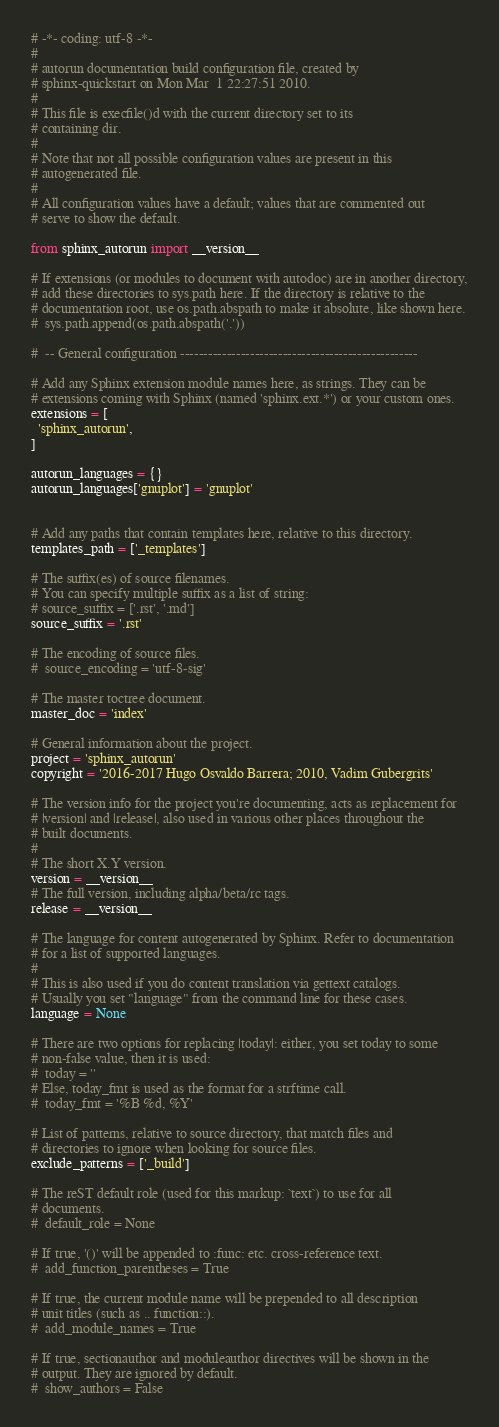Convert code to text. <code><loc_0><loc_0><loc_500><loc_500><_Python_># -*- coding: utf-8 -*-
#
# autorun documentation build configuration file, created by
# sphinx-quickstart on Mon Mar  1 22:27:51 2010.
#
# This file is execfile()d with the current directory set to its
# containing dir.
#
# Note that not all possible configuration values are present in this
# autogenerated file.
#
# All configuration values have a default; values that are commented out
# serve to show the default.

from sphinx_autorun import __version__

# If extensions (or modules to document with autodoc) are in another directory,
# add these directories to sys.path here. If the directory is relative to the
# documentation root, use os.path.abspath to make it absolute, like shown here.
#  sys.path.append(os.path.abspath('.'))

#  -- General configuration ---------------------------------------------------

# Add any Sphinx extension module names here, as strings. They can be
# extensions coming with Sphinx (named 'sphinx.ext.*') or your custom ones.
extensions = [
  'sphinx_autorun',
]

autorun_languages = {}
autorun_languages['gnuplot'] = 'gnuplot'


# Add any paths that contain templates here, relative to this directory.
templates_path = ['_templates']

# The suffix(es) of source filenames.
# You can specify multiple suffix as a list of string:
# source_suffix = ['.rst', '.md']
source_suffix = '.rst'

# The encoding of source files.
#  source_encoding = 'utf-8-sig'

# The master toctree document.
master_doc = 'index'

# General information about the project.
project = 'sphinx_autorun'
copyright = '2016-2017 Hugo Osvaldo Barrera; 2010, Vadim Gubergrits'

# The version info for the project you're documenting, acts as replacement for
# |version| and |release|, also used in various other places throughout the
# built documents.
#
# The short X.Y version.
version = __version__
# The full version, including alpha/beta/rc tags.
release = __version__

# The language for content autogenerated by Sphinx. Refer to documentation
# for a list of supported languages.
#
# This is also used if you do content translation via gettext catalogs.
# Usually you set "language" from the command line for these cases.
language = None

# There are two options for replacing |today|: either, you set today to some
# non-false value, then it is used:
#  today = ''
# Else, today_fmt is used as the format for a strftime call.
#  today_fmt = '%B %d, %Y'

# List of patterns, relative to source directory, that match files and
# directories to ignore when looking for source files.
exclude_patterns = ['_build']

# The reST default role (used for this markup: `text`) to use for all
# documents.
#  default_role = None

# If true, '()' will be appended to :func: etc. cross-reference text.
#  add_function_parentheses = True

# If true, the current module name will be prepended to all description
# unit titles (such as .. function::).
#  add_module_names = True

# If true, sectionauthor and moduleauthor directives will be shown in the
# output. They are ignored by default.
#  show_authors = False
</code> 